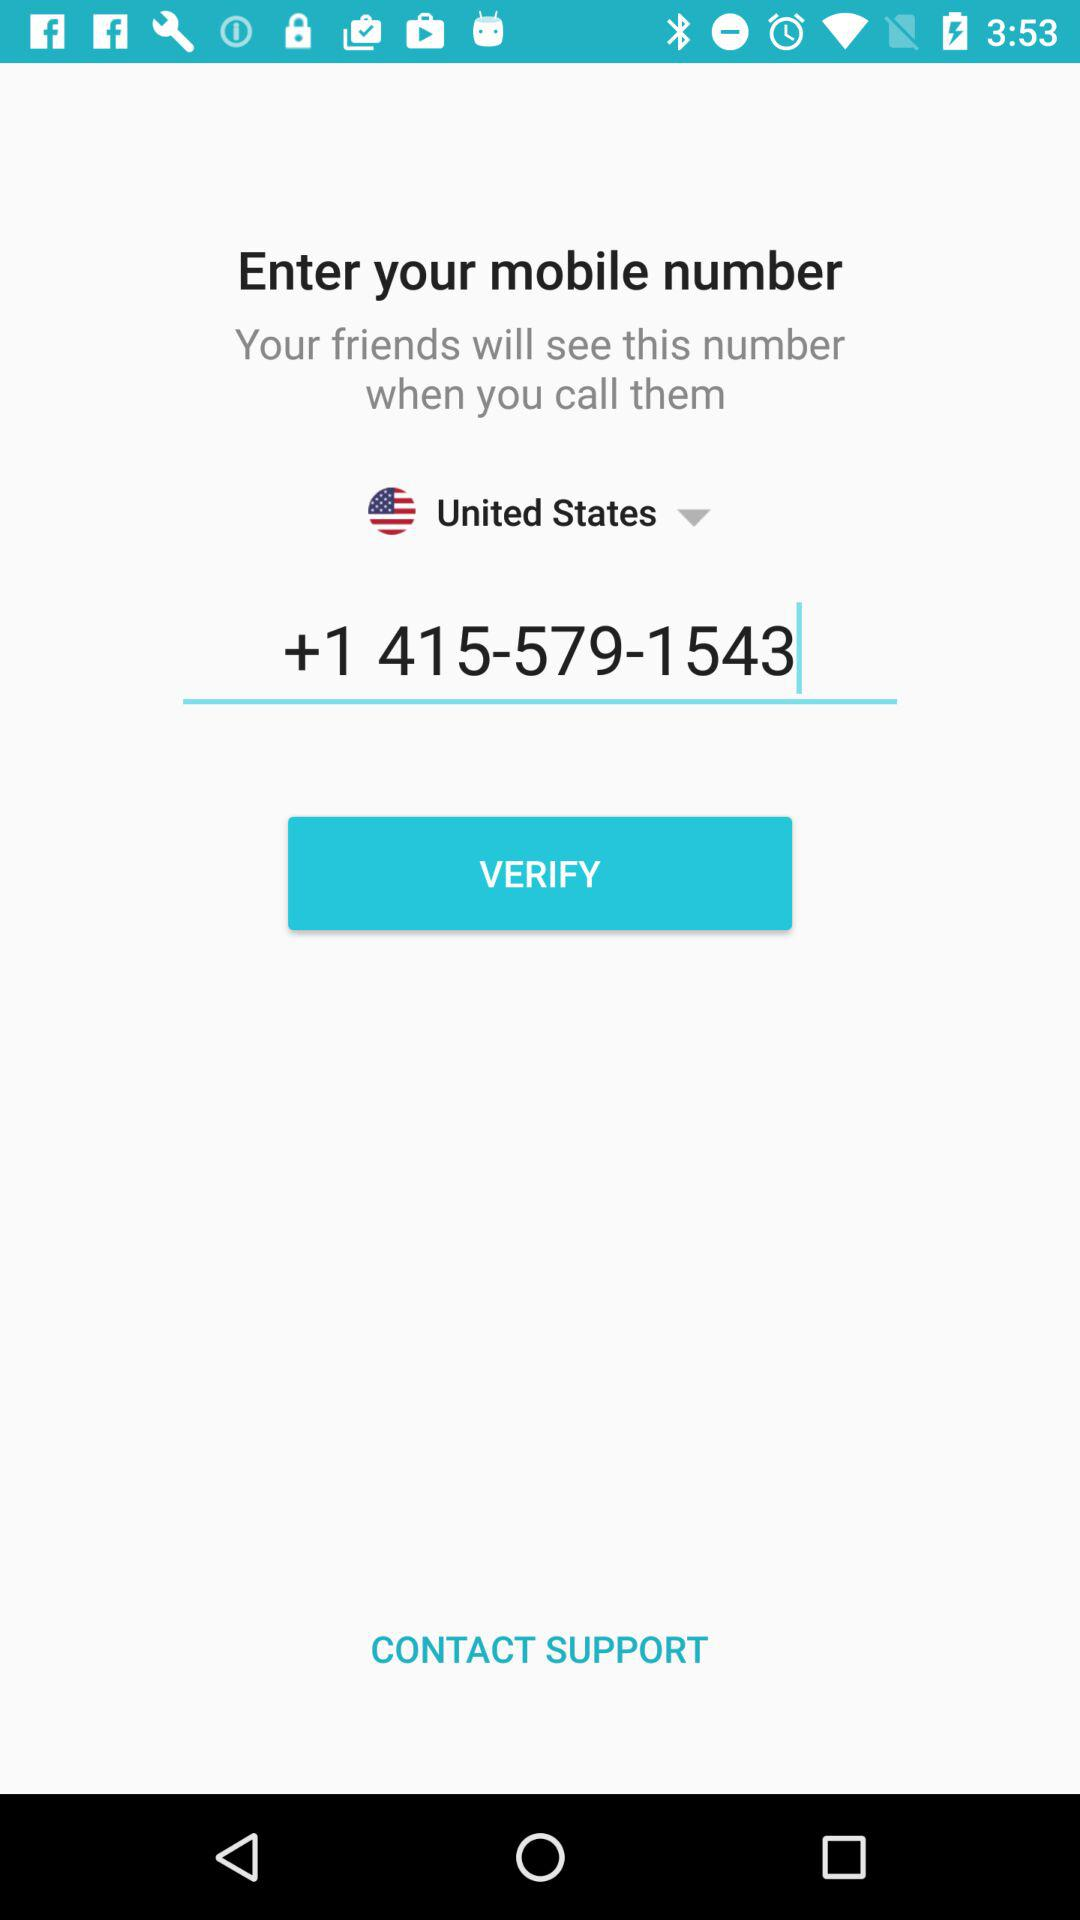What is the selected country? The selected country is the United States. 